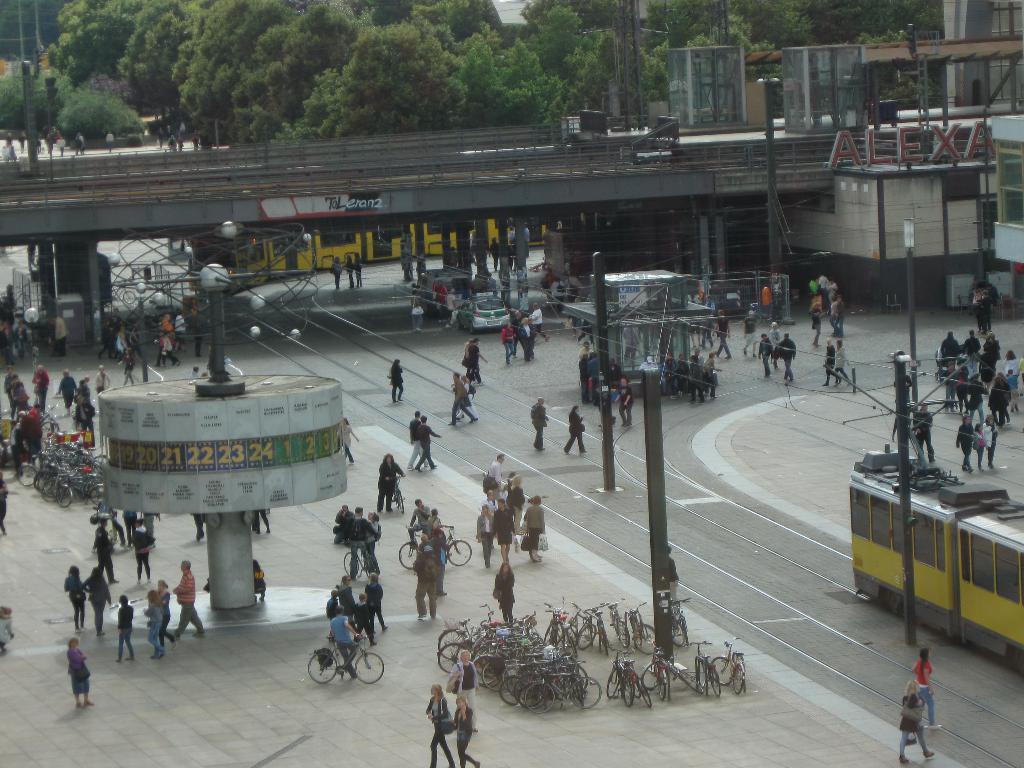In one or two sentences, can you explain what this image depicts? In this image we can see a few people, some of them are riding on the bicycles, there are poles, trains, a vehicle on the road, there are buildings, rooftops, also we can see trees, and board with text on it. 